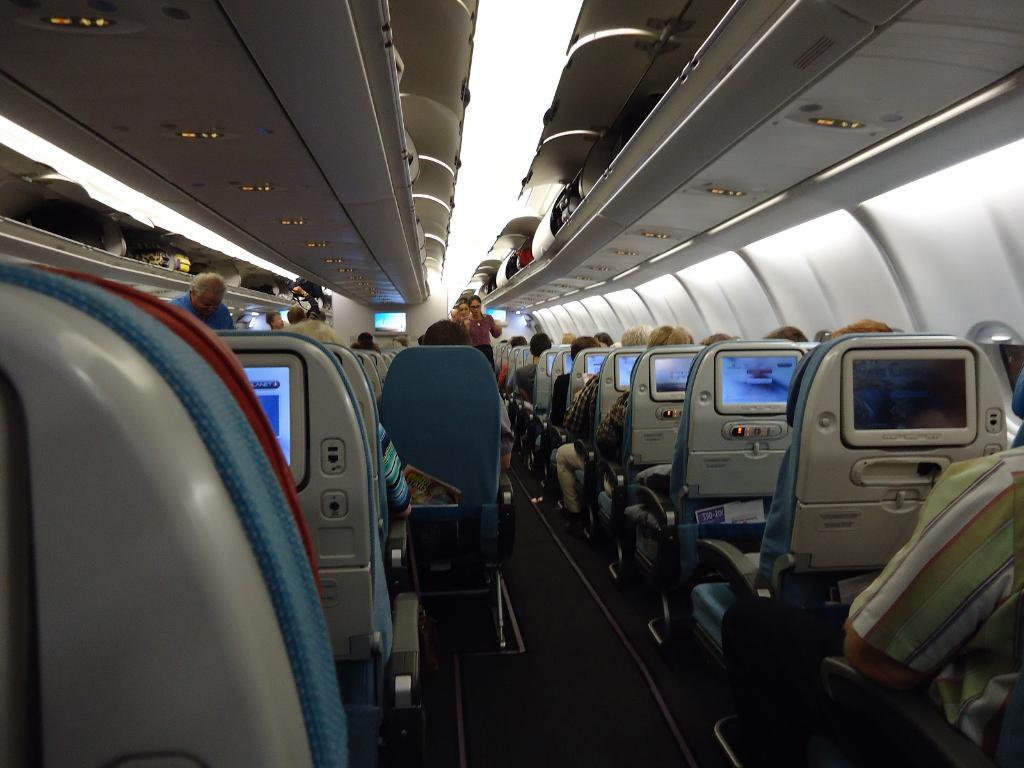What type of location is depicted in the image? The image shows an inside view of an airplane. What type of furniture is present in the airplane? There are chairs in the airplane. What are some people doing in the airplane? Some people are sitting on the chairs, and there is a person standing in the airplane. What type of technology is visible in the airplane? There are screens visible in the airplane. Can you see any letters being written by a cow in the image? There are no cows or letters being written in the image; it shows an inside view of an airplane with chairs, people, and screens. 